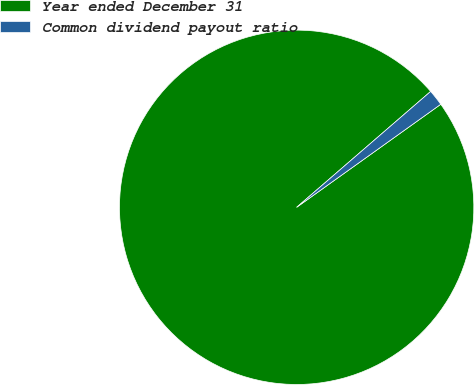Convert chart to OTSL. <chart><loc_0><loc_0><loc_500><loc_500><pie_chart><fcel>Year ended December 31<fcel>Common dividend payout ratio<nl><fcel>98.53%<fcel>1.47%<nl></chart> 